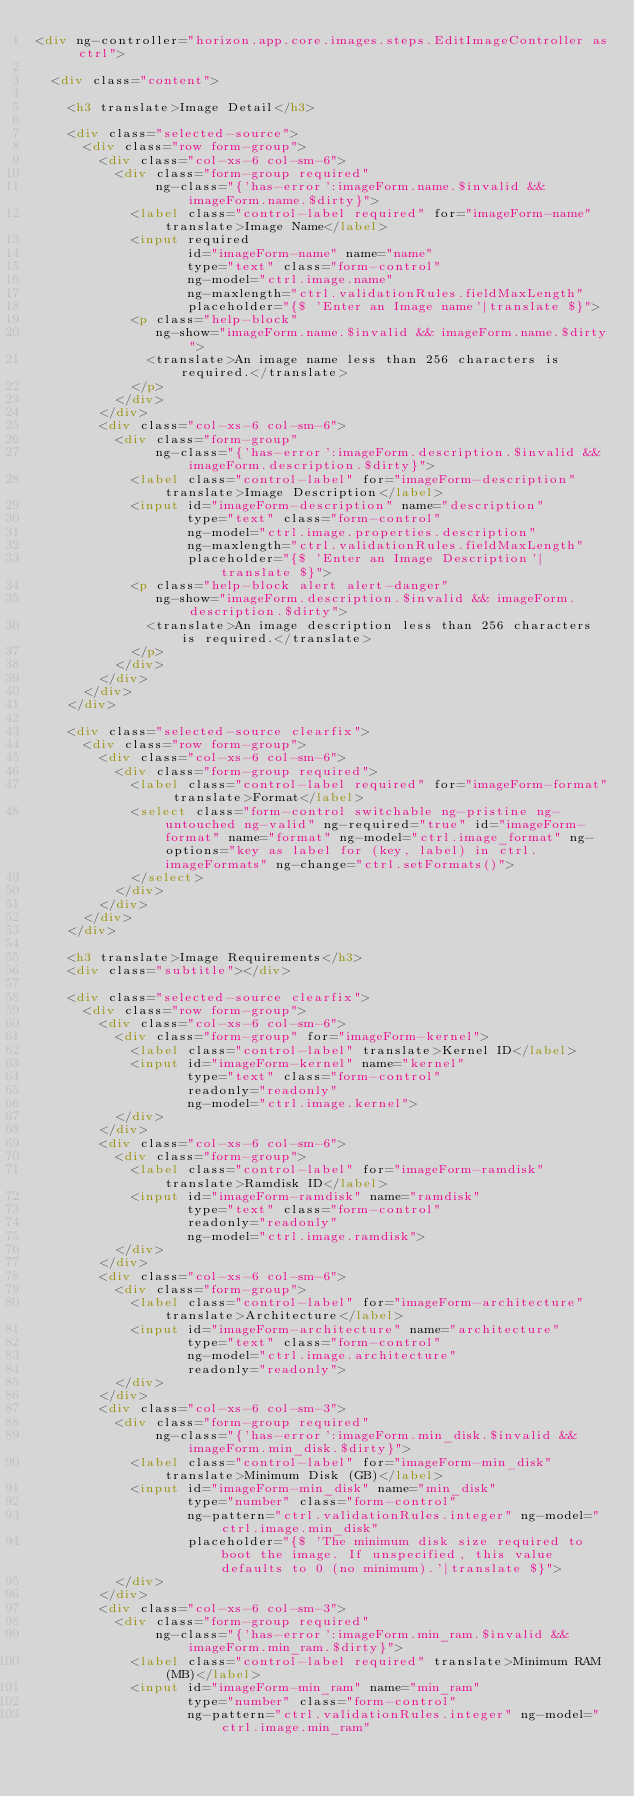<code> <loc_0><loc_0><loc_500><loc_500><_HTML_><div ng-controller="horizon.app.core.images.steps.EditImageController as ctrl">

  <div class="content">

    <h3 translate>Image Detail</h3>

    <div class="selected-source">
      <div class="row form-group">
        <div class="col-xs-6 col-sm-6">
          <div class="form-group required"
               ng-class="{'has-error':imageForm.name.$invalid && imageForm.name.$dirty}">
            <label class="control-label required" for="imageForm-name" translate>Image Name</label>
            <input required
                   id="imageForm-name" name="name"
                   type="text" class="form-control"
                   ng-model="ctrl.image.name"
                   ng-maxlength="ctrl.validationRules.fieldMaxLength"
                   placeholder="{$ 'Enter an Image name'|translate $}">
            <p class="help-block"
               ng-show="imageForm.name.$invalid && imageForm.name.$dirty">
              <translate>An image name less than 256 characters is required.</translate>
            </p>
          </div>
        </div>
        <div class="col-xs-6 col-sm-6">
          <div class="form-group"
               ng-class="{'has-error':imageForm.description.$invalid && imageForm.description.$dirty}">
            <label class="control-label" for="imageForm-description" translate>Image Description</label>
            <input id="imageForm-description" name="description"
                   type="text" class="form-control"
                   ng-model="ctrl.image.properties.description"
                   ng-maxlength="ctrl.validationRules.fieldMaxLength"
                   placeholder="{$ 'Enter an Image Description'|translate $}">
            <p class="help-block alert alert-danger"
               ng-show="imageForm.description.$invalid && imageForm.description.$dirty">
              <translate>An image description less than 256 characters is required.</translate>
            </p>
          </div>
        </div>
      </div>
    </div>

    <div class="selected-source clearfix">
      <div class="row form-group">
        <div class="col-xs-6 col-sm-6">
          <div class="form-group required">
            <label class="control-label required" for="imageForm-format" translate>Format</label>
            <select class="form-control switchable ng-pristine ng-untouched ng-valid" ng-required="true" id="imageForm-format" name="format" ng-model="ctrl.image_format" ng-options="key as label for (key, label) in ctrl.imageFormats" ng-change="ctrl.setFormats()">
            </select>
          </div>
        </div>
      </div>
    </div>

    <h3 translate>Image Requirements</h3>
    <div class="subtitle"></div>

    <div class="selected-source clearfix">
      <div class="row form-group">
        <div class="col-xs-6 col-sm-6">
          <div class="form-group" for="imageForm-kernel">
            <label class="control-label" translate>Kernel ID</label>
            <input id="imageForm-kernel" name="kernel"
                   type="text" class="form-control"
                   readonly="readonly"
                   ng-model="ctrl.image.kernel">
          </div>
        </div>
        <div class="col-xs-6 col-sm-6">
          <div class="form-group">
            <label class="control-label" for="imageForm-ramdisk" translate>Ramdisk ID</label>
            <input id="imageForm-ramdisk" name="ramdisk"
                   type="text" class="form-control"
                   readonly="readonly"
                   ng-model="ctrl.image.ramdisk">
          </div>
        </div>
        <div class="col-xs-6 col-sm-6">
          <div class="form-group">
            <label class="control-label" for="imageForm-architecture" translate>Architecture</label>
            <input id="imageForm-architecture" name="architecture"
                   type="text" class="form-control"
                   ng-model="ctrl.image.architecture"
                   readonly="readonly">
          </div>
        </div>
        <div class="col-xs-6 col-sm-3">
          <div class="form-group required"
               ng-class="{'has-error':imageForm.min_disk.$invalid && imageForm.min_disk.$dirty}">
            <label class="control-label" for="imageForm-min_disk" translate>Minimum Disk (GB)</label>
            <input id="imageForm-min_disk" name="min_disk"
                   type="number" class="form-control"
                   ng-pattern="ctrl.validationRules.integer" ng-model="ctrl.image.min_disk"
                   placeholder="{$ 'The minimum disk size required to boot the image. If unspecified, this value defaults to 0 (no minimum).'|translate $}">
          </div>
        </div>
        <div class="col-xs-6 col-sm-3">
          <div class="form-group required"
               ng-class="{'has-error':imageForm.min_ram.$invalid && imageForm.min_ram.$dirty}">
            <label class="control-label required" translate>Minimum RAM (MB)</label>
            <input id="imageForm-min_ram" name="min_ram"
                   type="number" class="form-control"
                   ng-pattern="ctrl.validationRules.integer" ng-model="ctrl.image.min_ram"</code> 